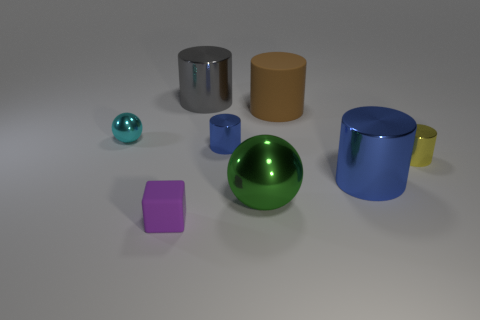Subtract all yellow cubes. How many blue cylinders are left? 2 Subtract all rubber cylinders. How many cylinders are left? 4 Add 1 large gray metallic cylinders. How many objects exist? 9 Subtract all brown cylinders. How many cylinders are left? 4 Subtract all yellow cylinders. Subtract all cyan balls. How many cylinders are left? 4 Subtract all cylinders. How many objects are left? 3 Add 4 shiny balls. How many shiny balls are left? 6 Add 6 small purple rubber things. How many small purple rubber things exist? 7 Subtract 0 gray cubes. How many objects are left? 8 Subtract all big cyan cylinders. Subtract all small yellow objects. How many objects are left? 7 